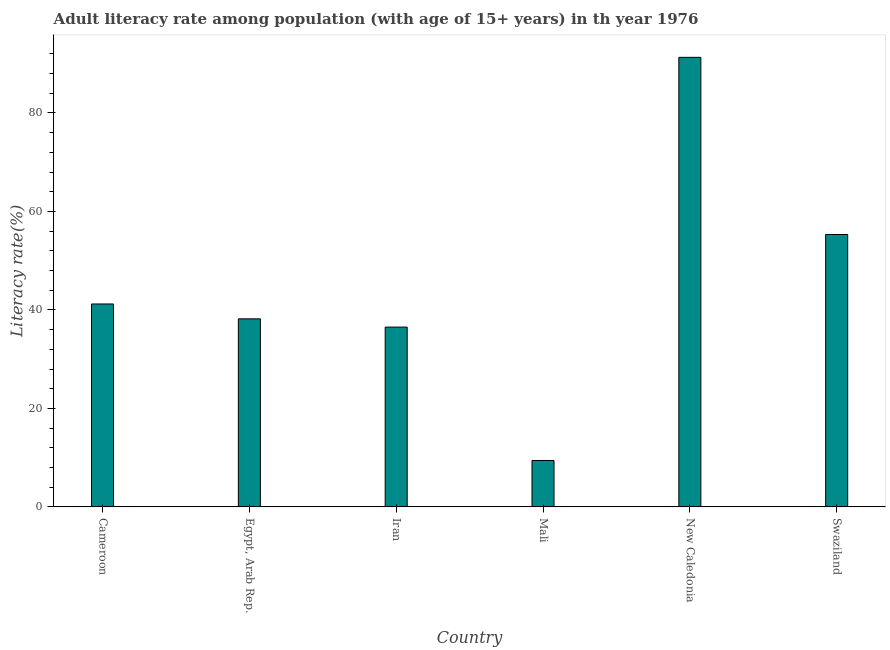Does the graph contain any zero values?
Give a very brief answer. No. What is the title of the graph?
Ensure brevity in your answer.  Adult literacy rate among population (with age of 15+ years) in th year 1976. What is the label or title of the Y-axis?
Offer a very short reply. Literacy rate(%). What is the adult literacy rate in Cameroon?
Keep it short and to the point. 41.22. Across all countries, what is the maximum adult literacy rate?
Ensure brevity in your answer.  91.3. Across all countries, what is the minimum adult literacy rate?
Offer a very short reply. 9.43. In which country was the adult literacy rate maximum?
Your answer should be compact. New Caledonia. In which country was the adult literacy rate minimum?
Your answer should be very brief. Mali. What is the sum of the adult literacy rate?
Your answer should be very brief. 271.99. What is the difference between the adult literacy rate in Mali and New Caledonia?
Provide a short and direct response. -81.87. What is the average adult literacy rate per country?
Make the answer very short. 45.33. What is the median adult literacy rate?
Your response must be concise. 39.71. In how many countries, is the adult literacy rate greater than 36 %?
Offer a very short reply. 5. What is the ratio of the adult literacy rate in New Caledonia to that in Swaziland?
Your response must be concise. 1.65. Is the difference between the adult literacy rate in Iran and New Caledonia greater than the difference between any two countries?
Your answer should be compact. No. What is the difference between the highest and the second highest adult literacy rate?
Your answer should be very brief. 35.98. What is the difference between the highest and the lowest adult literacy rate?
Offer a very short reply. 81.87. How many bars are there?
Provide a succinct answer. 6. What is the difference between two consecutive major ticks on the Y-axis?
Make the answer very short. 20. What is the Literacy rate(%) in Cameroon?
Your answer should be very brief. 41.22. What is the Literacy rate(%) of Egypt, Arab Rep.?
Offer a very short reply. 38.2. What is the Literacy rate(%) of Iran?
Ensure brevity in your answer.  36.52. What is the Literacy rate(%) in Mali?
Provide a succinct answer. 9.43. What is the Literacy rate(%) of New Caledonia?
Provide a short and direct response. 91.3. What is the Literacy rate(%) in Swaziland?
Your response must be concise. 55.33. What is the difference between the Literacy rate(%) in Cameroon and Egypt, Arab Rep.?
Offer a terse response. 3.02. What is the difference between the Literacy rate(%) in Cameroon and Iran?
Your answer should be compact. 4.7. What is the difference between the Literacy rate(%) in Cameroon and Mali?
Give a very brief answer. 31.78. What is the difference between the Literacy rate(%) in Cameroon and New Caledonia?
Your answer should be very brief. -50.08. What is the difference between the Literacy rate(%) in Cameroon and Swaziland?
Ensure brevity in your answer.  -14.11. What is the difference between the Literacy rate(%) in Egypt, Arab Rep. and Iran?
Provide a short and direct response. 1.68. What is the difference between the Literacy rate(%) in Egypt, Arab Rep. and Mali?
Ensure brevity in your answer.  28.76. What is the difference between the Literacy rate(%) in Egypt, Arab Rep. and New Caledonia?
Make the answer very short. -53.1. What is the difference between the Literacy rate(%) in Egypt, Arab Rep. and Swaziland?
Provide a short and direct response. -17.13. What is the difference between the Literacy rate(%) in Iran and Mali?
Make the answer very short. 27.08. What is the difference between the Literacy rate(%) in Iran and New Caledonia?
Keep it short and to the point. -54.78. What is the difference between the Literacy rate(%) in Iran and Swaziland?
Provide a succinct answer. -18.81. What is the difference between the Literacy rate(%) in Mali and New Caledonia?
Keep it short and to the point. -81.87. What is the difference between the Literacy rate(%) in Mali and Swaziland?
Make the answer very short. -45.89. What is the difference between the Literacy rate(%) in New Caledonia and Swaziland?
Offer a terse response. 35.98. What is the ratio of the Literacy rate(%) in Cameroon to that in Egypt, Arab Rep.?
Your answer should be very brief. 1.08. What is the ratio of the Literacy rate(%) in Cameroon to that in Iran?
Provide a short and direct response. 1.13. What is the ratio of the Literacy rate(%) in Cameroon to that in Mali?
Ensure brevity in your answer.  4.37. What is the ratio of the Literacy rate(%) in Cameroon to that in New Caledonia?
Offer a terse response. 0.45. What is the ratio of the Literacy rate(%) in Cameroon to that in Swaziland?
Your answer should be compact. 0.74. What is the ratio of the Literacy rate(%) in Egypt, Arab Rep. to that in Iran?
Provide a succinct answer. 1.05. What is the ratio of the Literacy rate(%) in Egypt, Arab Rep. to that in Mali?
Your response must be concise. 4.05. What is the ratio of the Literacy rate(%) in Egypt, Arab Rep. to that in New Caledonia?
Offer a very short reply. 0.42. What is the ratio of the Literacy rate(%) in Egypt, Arab Rep. to that in Swaziland?
Keep it short and to the point. 0.69. What is the ratio of the Literacy rate(%) in Iran to that in Mali?
Your answer should be very brief. 3.87. What is the ratio of the Literacy rate(%) in Iran to that in New Caledonia?
Your answer should be very brief. 0.4. What is the ratio of the Literacy rate(%) in Iran to that in Swaziland?
Provide a succinct answer. 0.66. What is the ratio of the Literacy rate(%) in Mali to that in New Caledonia?
Your answer should be very brief. 0.1. What is the ratio of the Literacy rate(%) in Mali to that in Swaziland?
Offer a very short reply. 0.17. What is the ratio of the Literacy rate(%) in New Caledonia to that in Swaziland?
Ensure brevity in your answer.  1.65. 